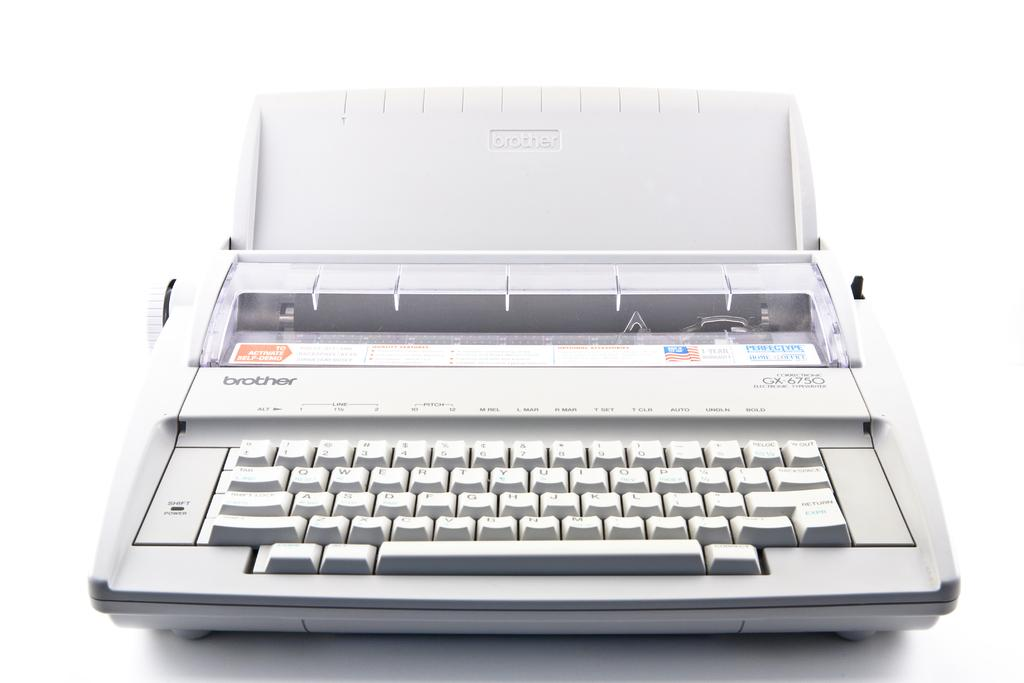<image>
Create a compact narrative representing the image presented. The brother GX-6750 electric typewriter is against a white background. 